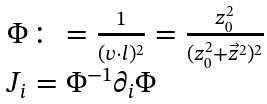Convert formula to latex. <formula><loc_0><loc_0><loc_500><loc_500>\begin{array} { l } { { \Phi \colon = { \frac { 1 } { ( v \cdot l ) ^ { 2 } } } = { \frac { z _ { 0 } ^ { 2 } } { ( z _ { 0 } ^ { 2 } + \vec { z } ^ { 2 } ) ^ { 2 } } } } } \\ { { J _ { i } = \Phi ^ { - 1 } \partial _ { i } \Phi } } \end{array}</formula> 